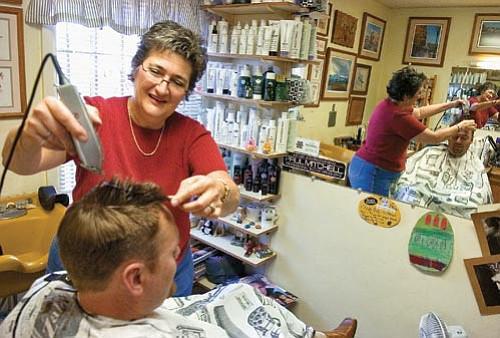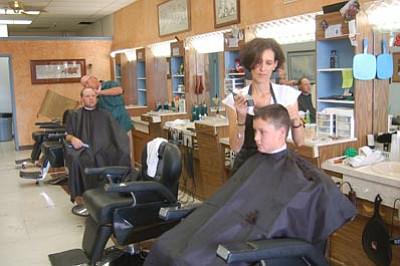The first image is the image on the left, the second image is the image on the right. Assess this claim about the two images: "In one image, a male and a female barber are both working on seated customers, with an empty chair between them.". Correct or not? Answer yes or no. Yes. The first image is the image on the left, the second image is the image on the right. Considering the images on both sides, is "The foreground of one image features a woman in a black apron standing behind a leftward facing male wearing a smock." valid? Answer yes or no. Yes. 